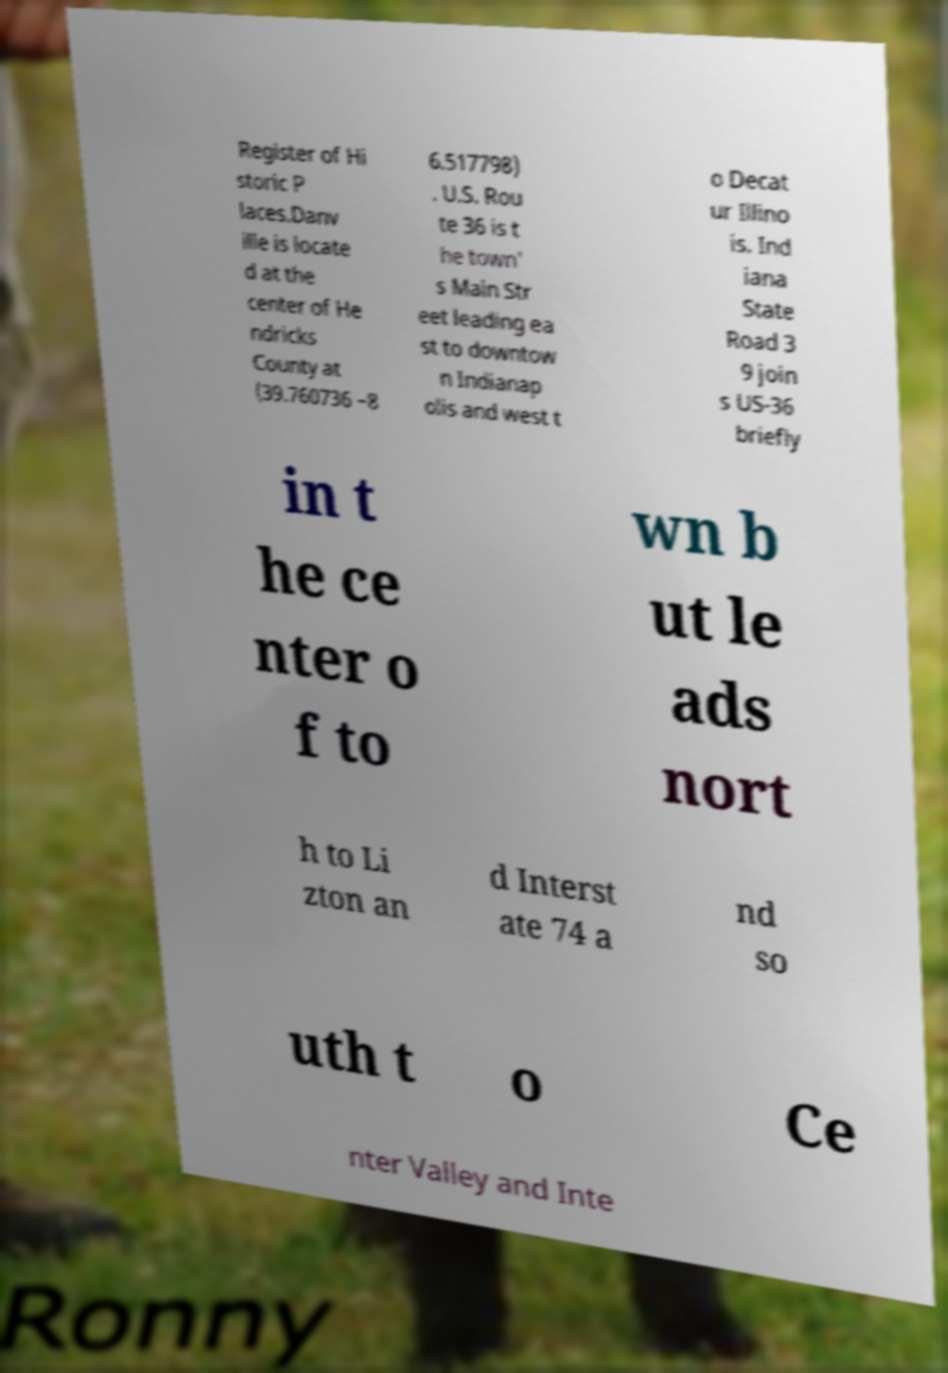Could you extract and type out the text from this image? Register of Hi storic P laces.Danv ille is locate d at the center of He ndricks County at (39.760736 −8 6.517798) . U.S. Rou te 36 is t he town' s Main Str eet leading ea st to downtow n Indianap olis and west t o Decat ur Illino is. Ind iana State Road 3 9 join s US-36 briefly in t he ce nter o f to wn b ut le ads nort h to Li zton an d Interst ate 74 a nd so uth t o Ce nter Valley and Inte 